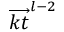Convert formula to latex. <formula><loc_0><loc_0><loc_500><loc_500>\overrightarrow { k t } ^ { l - 2 }</formula> 